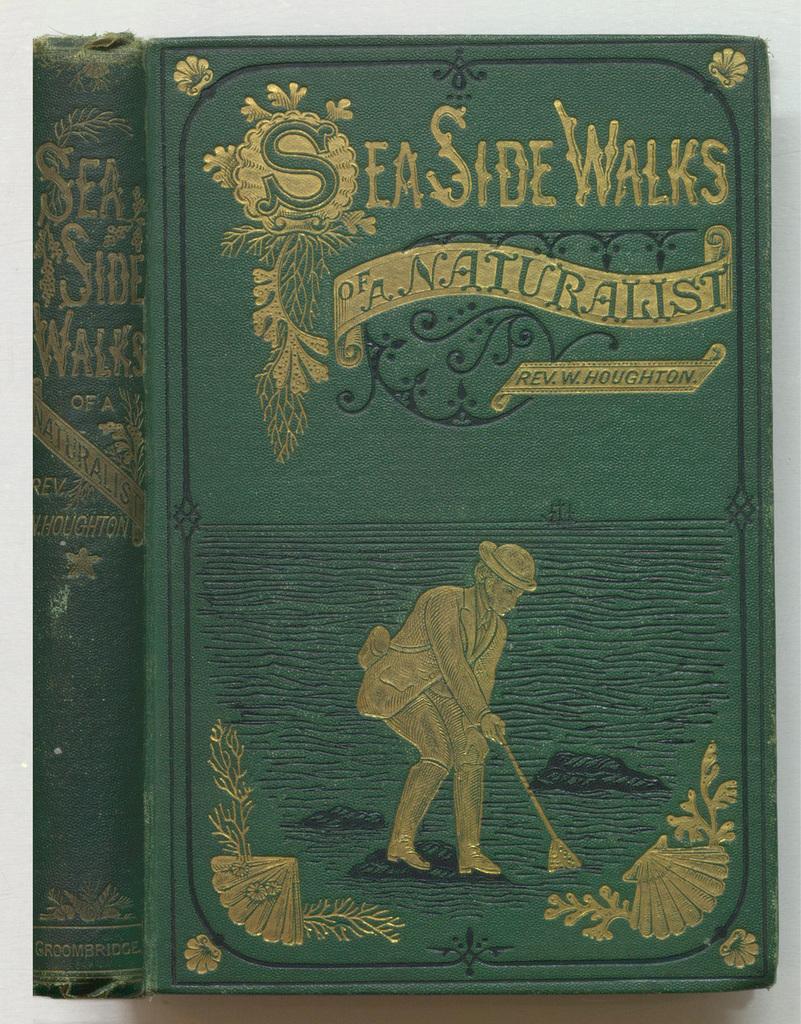What is the title of the book?
Keep it short and to the point. Seaside walks of a naturalist. 